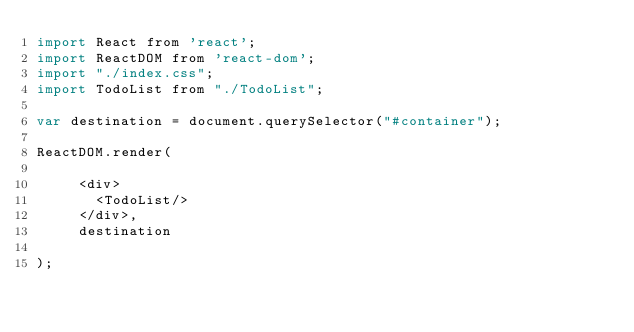<code> <loc_0><loc_0><loc_500><loc_500><_JavaScript_>import React from 'react';
import ReactDOM from 'react-dom';
import "./index.css";
import TodoList from "./TodoList";

var destination = document.querySelector("#container");

ReactDOM.render(

     <div>
       <TodoList/>
     </div>,
     destination

);


</code> 